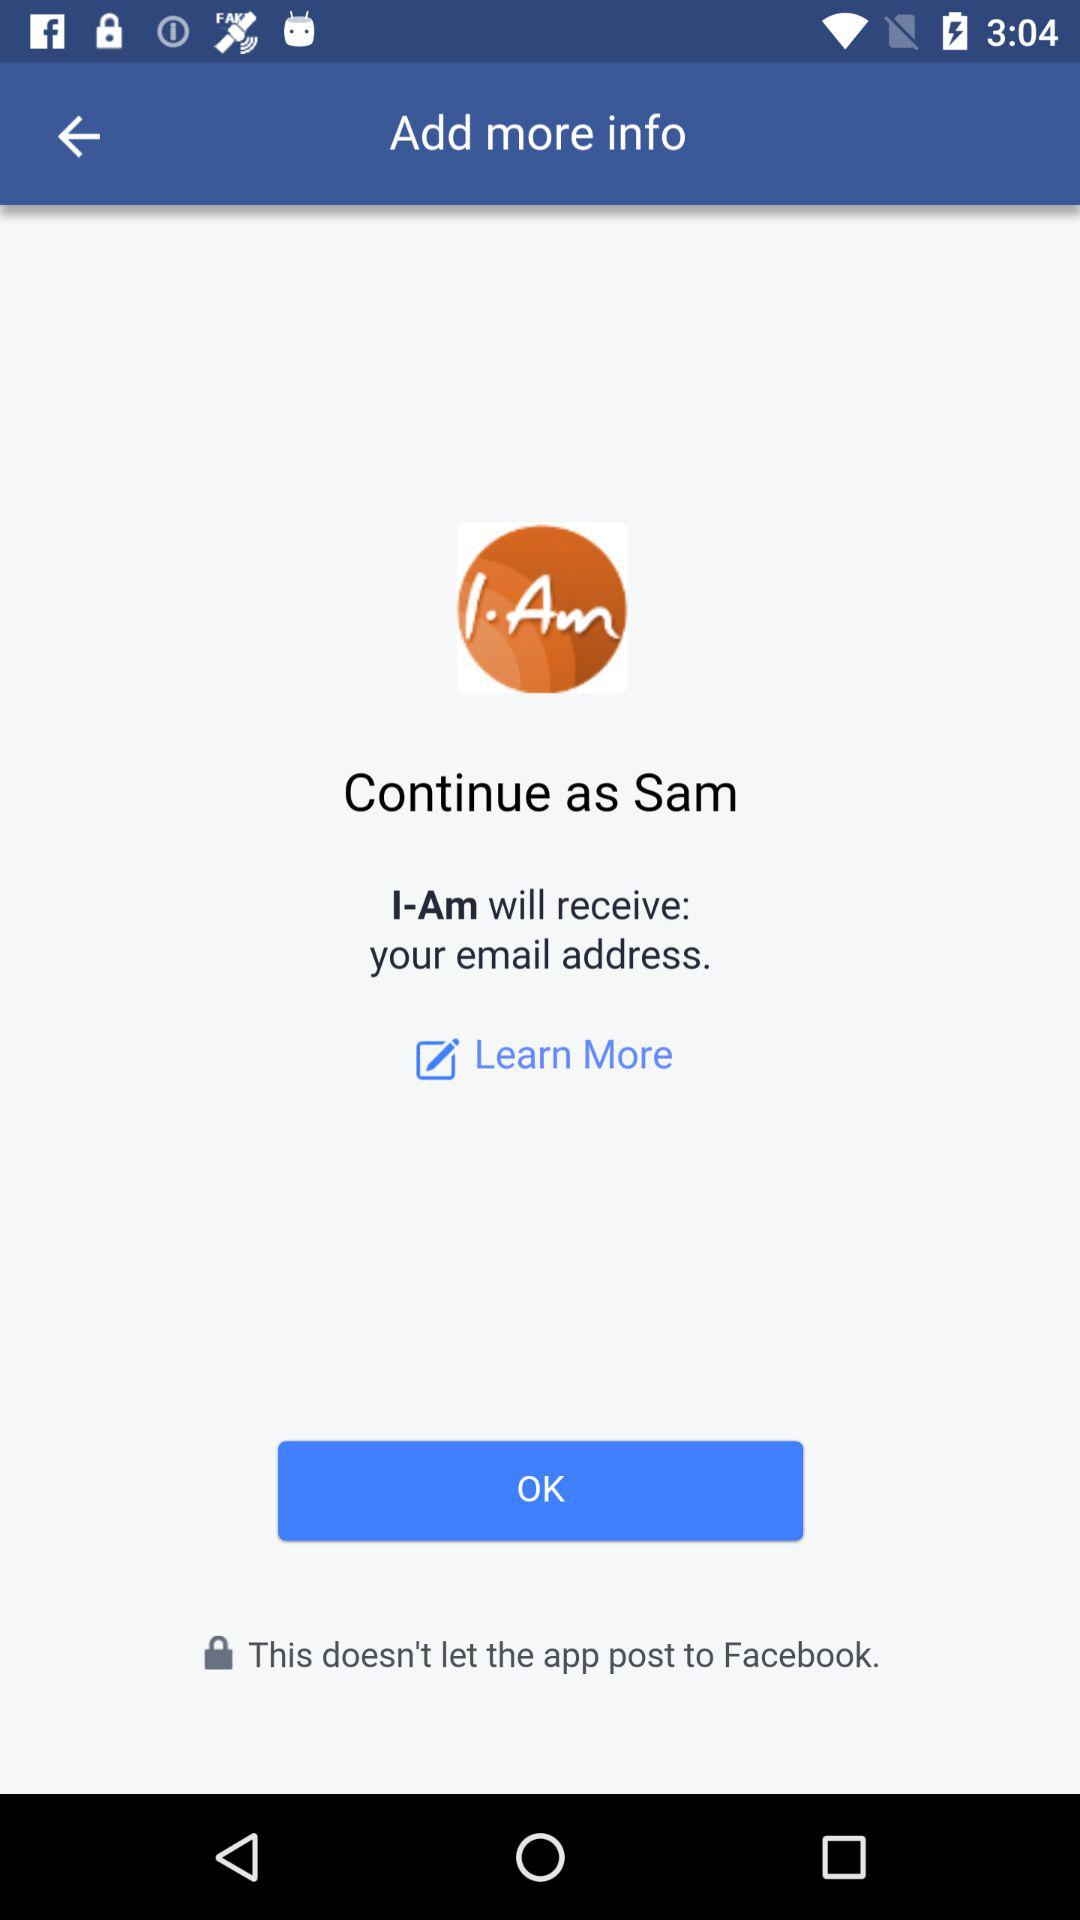What is the information provided in "Learn More"?
When the provided information is insufficient, respond with <no answer>. <no answer> 